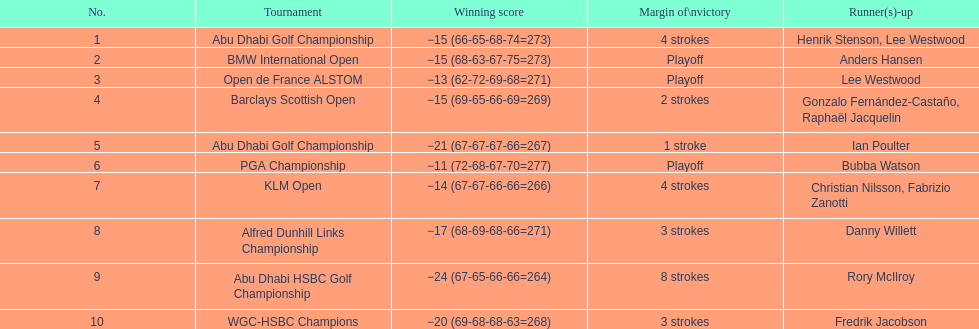Who secured the top score in the pga championship? Bubba Watson. 